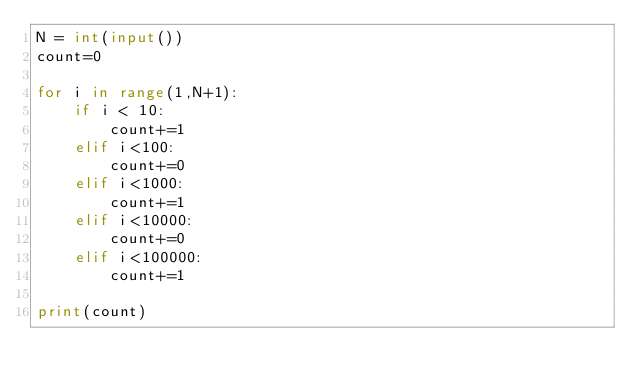<code> <loc_0><loc_0><loc_500><loc_500><_Python_>N = int(input())
count=0

for i in range(1,N+1):
    if i < 10:
        count+=1
    elif i<100:
        count+=0
    elif i<1000:
        count+=1
    elif i<10000:
        count+=0
    elif i<100000:
        count+=1

print(count)</code> 